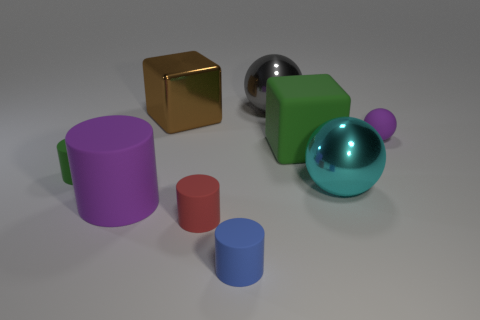What is the shape of the blue object that is made of the same material as the tiny red object?
Keep it short and to the point. Cylinder. Are the red cylinder and the large gray sphere made of the same material?
Offer a terse response. No. Are there fewer purple objects that are in front of the matte sphere than small blue cylinders right of the big cyan metal object?
Provide a short and direct response. No. There is a thing that is the same color as the small rubber sphere; what is its size?
Ensure brevity in your answer.  Large. There is a metal ball that is behind the big matte object behind the green rubber cylinder; what number of big matte cubes are behind it?
Your response must be concise. 0. Does the metal block have the same color as the big matte block?
Provide a short and direct response. No. Are there any spheres of the same color as the big metal block?
Offer a terse response. No. What color is the ball that is the same size as the blue thing?
Give a very brief answer. Purple. Is there a gray thing that has the same shape as the large green thing?
Your response must be concise. No. What is the shape of the big matte thing that is the same color as the matte ball?
Your answer should be very brief. Cylinder. 